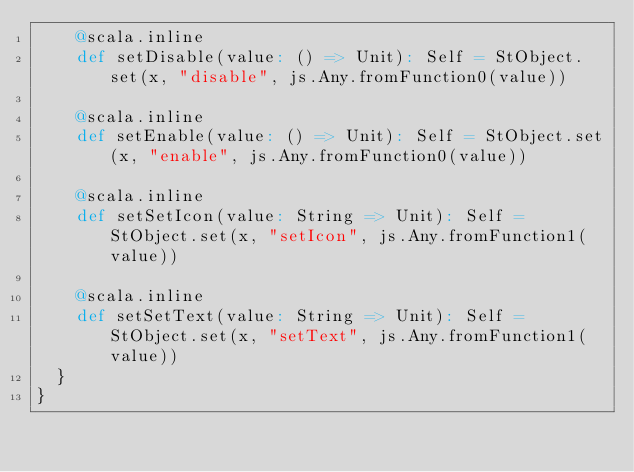<code> <loc_0><loc_0><loc_500><loc_500><_Scala_>    @scala.inline
    def setDisable(value: () => Unit): Self = StObject.set(x, "disable", js.Any.fromFunction0(value))
    
    @scala.inline
    def setEnable(value: () => Unit): Self = StObject.set(x, "enable", js.Any.fromFunction0(value))
    
    @scala.inline
    def setSetIcon(value: String => Unit): Self = StObject.set(x, "setIcon", js.Any.fromFunction1(value))
    
    @scala.inline
    def setSetText(value: String => Unit): Self = StObject.set(x, "setText", js.Any.fromFunction1(value))
  }
}
</code> 